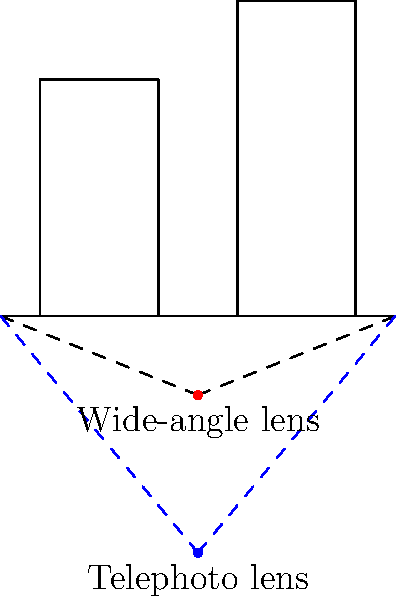In the street scene depicted above, two camera positions are shown: one using a wide-angle lens (red dot) and another using a telephoto lens (blue dot). How does the change in focal length affect the perspective and composition of the scene? To understand the impact of different focal lengths on perspective in this street scene, let's analyze the diagram step-by-step:

1. Wide-angle lens (red dot):
   - Positioned closer to the scene
   - Wider field of view (shown by red dashed lines)
   - Captures more of the scene in a single frame

2. Telephoto lens (blue dot):
   - Positioned further from the scene
   - Narrower field of view (shown by blue dashed lines)
   - Captures less of the scene in a single frame

3. Perspective effects:
   - Wide-angle lens:
     a. Exaggerates the sense of depth and distance
     b. Objects in the foreground appear larger and more prominent
     c. Background elements appear smaller and more distant
   - Telephoto lens:
     a. Compresses the sense of depth and distance
     b. Objects at different distances appear closer together
     c. Background elements appear larger and more prominent

4. Composition impact:
   - Wide-angle lens:
     a. Emphasizes leading lines and diagonal compositions
     b. Can create a sense of drama or exaggeration
     c. Useful for capturing expansive scenes or tight spaces
   - Telephoto lens:
     a. Isolates subjects and compresses layers in the scene
     b. Creates a flatter, more abstract composition
     c. Useful for emphasizing specific elements or details

5. Creative considerations:
   - Wide-angle lens can distort straight lines, especially near the edges of the frame
   - Telephoto lens can create a shallower depth of field, blurring background elements

The choice between these focal lengths depends on the desired perspective, composition, and creative vision for the photograph.
Answer: Wide-angle lens exaggerates depth and emphasizes foreground; telephoto lens compresses depth and emphasizes background. 